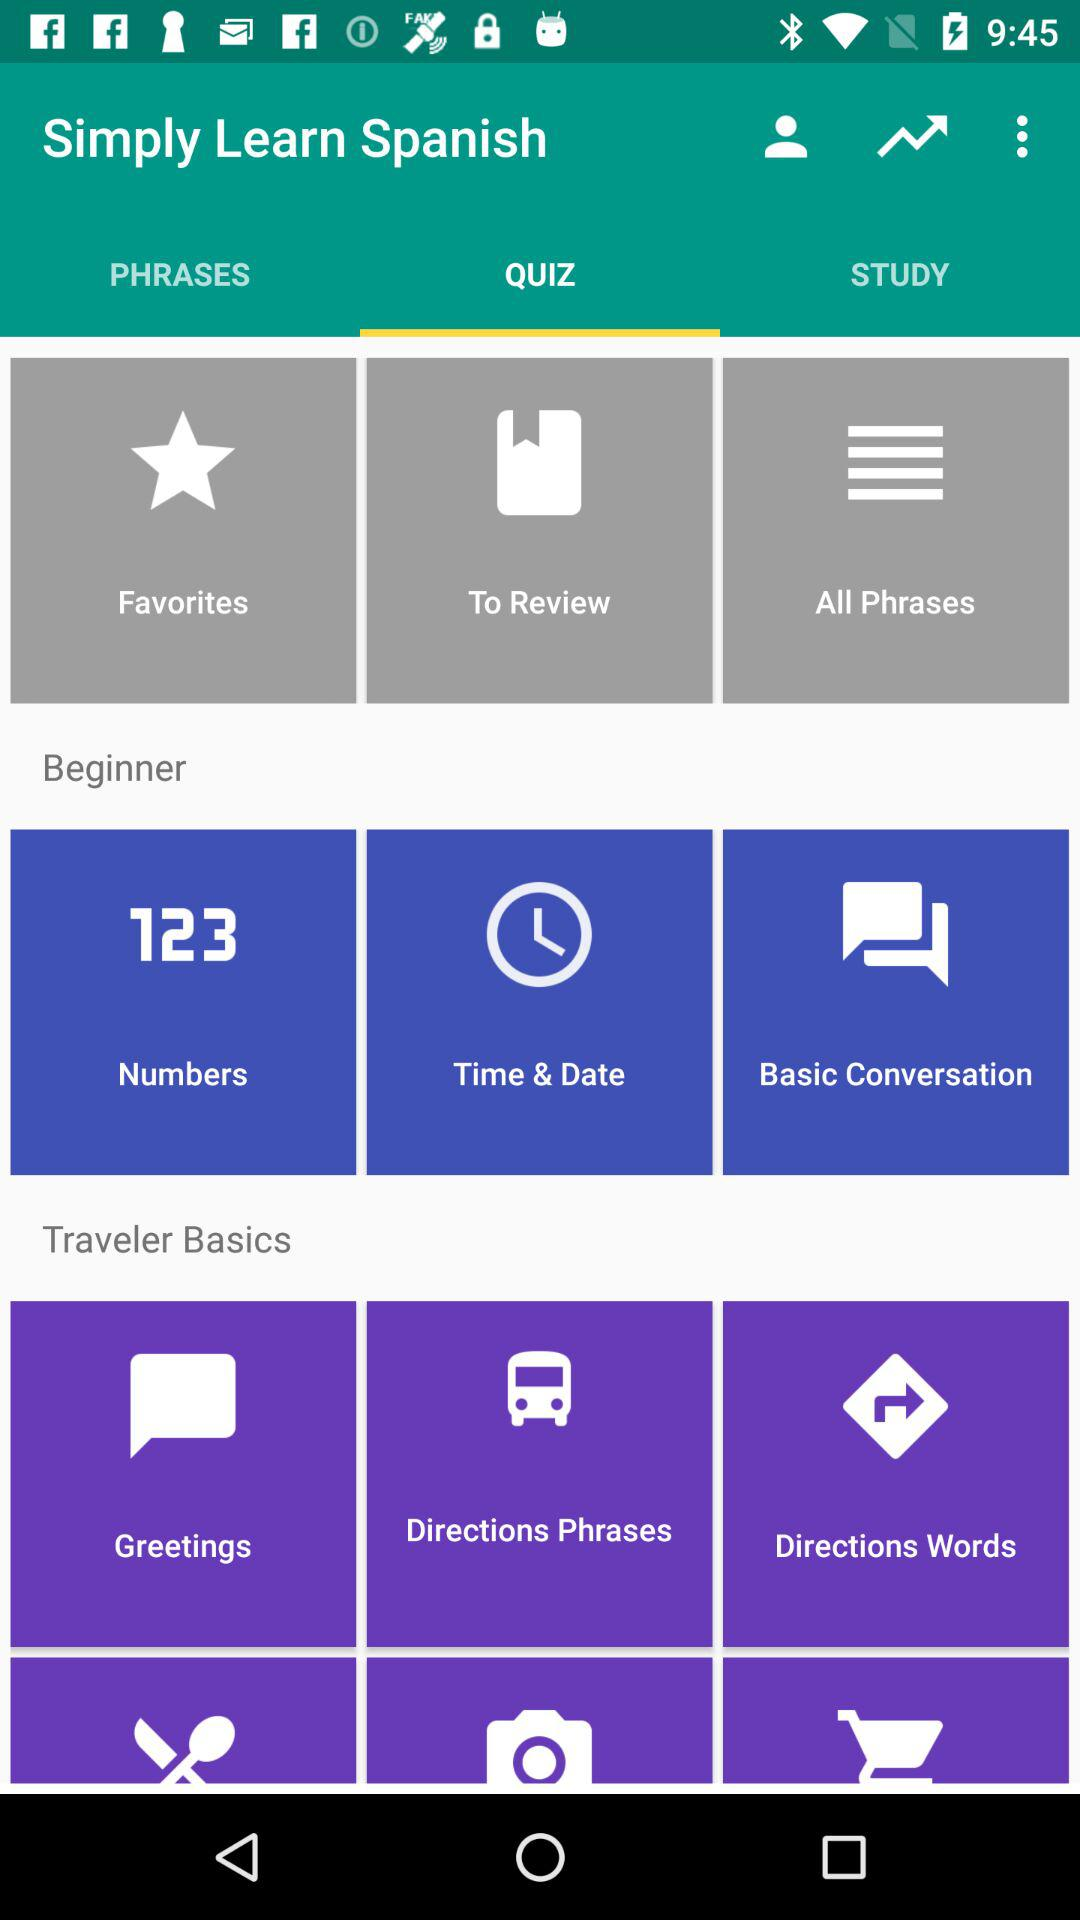What is the selected tab? The selected tab is "QUIZ". 